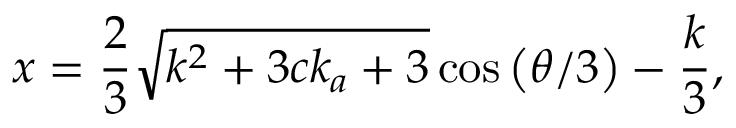<formula> <loc_0><loc_0><loc_500><loc_500>x = \frac { 2 } { 3 } \sqrt { k ^ { 2 } + 3 c k _ { a } + 3 } \cos { \left ( \theta / 3 \right ) } - \frac { k } { 3 } ,</formula> 